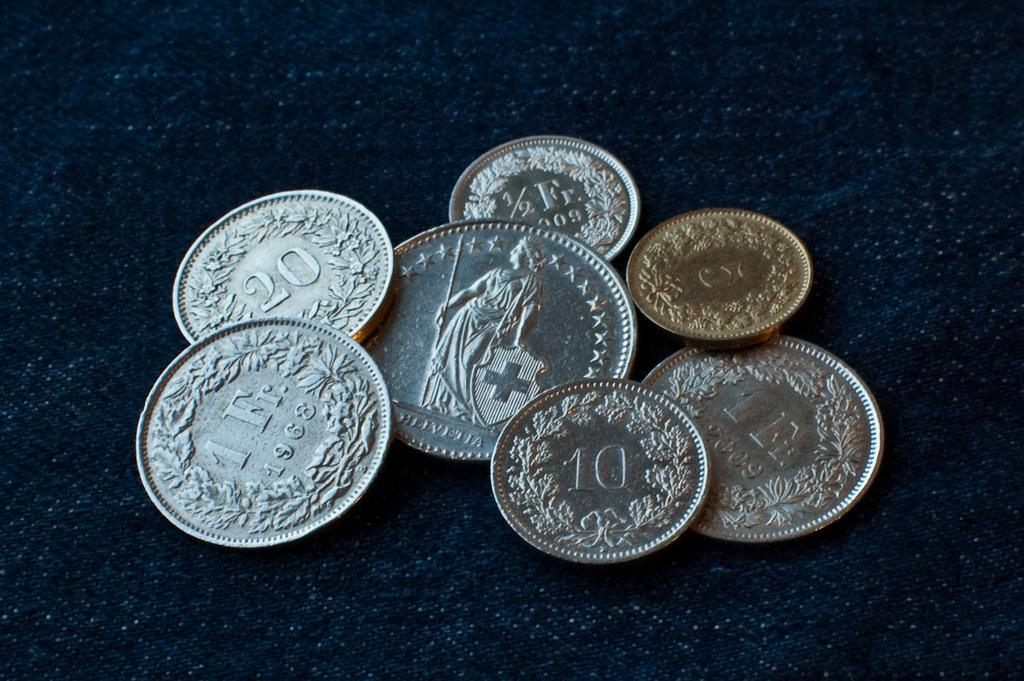<image>
Relay a brief, clear account of the picture shown. A bunch of silver and gold coins show denominations like 20. 